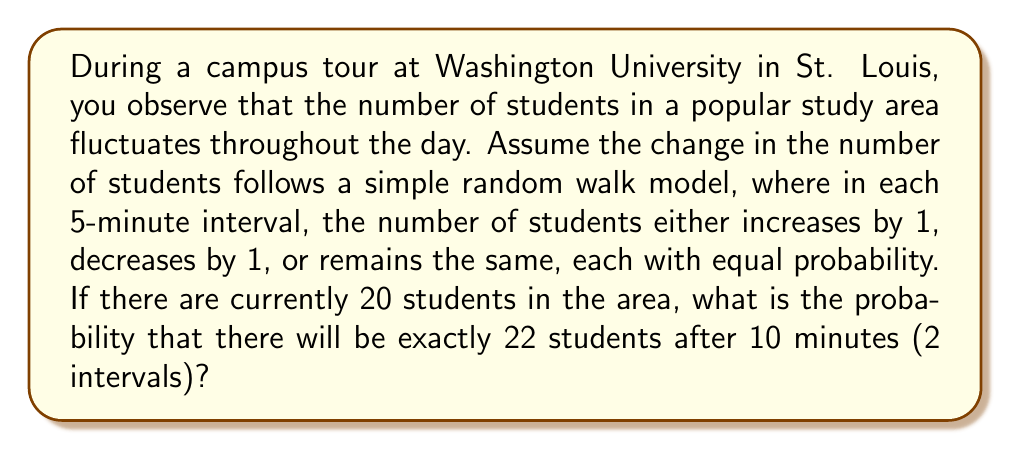Provide a solution to this math problem. Let's approach this step-by-step:

1) In this random walk model, we have three possible outcomes for each 5-minute interval:
   +1 (increase), 0 (no change), -1 (decrease), each with probability 1/3.

2) To get from 20 to 22 students in 2 intervals, we need a net increase of 2.

3) The possible combinations to achieve this are:
   (+1, +1), (+2, 0), (+0, +2)

4) Let's calculate the probability of each:

   P(+1, +1) = (1/3) * (1/3) = 1/9
   P(+2, 0) = (1/3) * (1/3) = 1/9
   P(0, +2) = (1/3) * (1/3) = 1/9

5) The total probability is the sum of these individual probabilities:

   $$P(\text{22 students after 10 minutes}) = \frac{1}{9} + \frac{1}{9} + \frac{1}{9} = \frac{3}{9} = \frac{1}{3}$$

Therefore, the probability of having exactly 22 students after 10 minutes is 1/3.
Answer: 1/3 